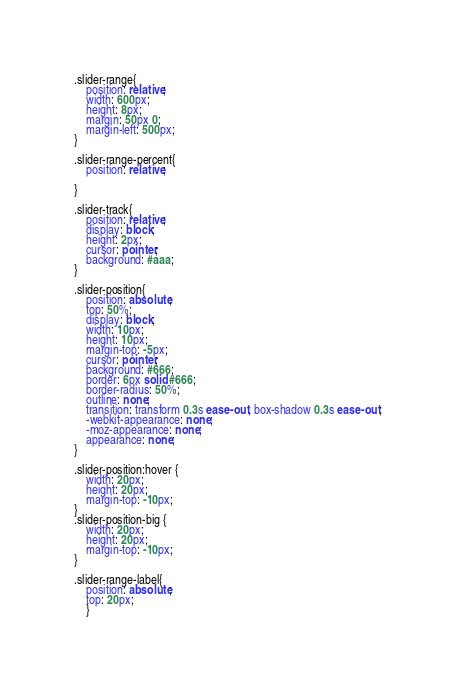<code> <loc_0><loc_0><loc_500><loc_500><_CSS_>.slider-range{
    position: relative;
    width: 600px;
    height: 8px;
    margin: 50px 0;
    margin-left: 500px;
}

.slider-range-percent{
    position: relative;
 
}

.slider-track{
    position: relative;
    display: block;
    height: 2px;
    cursor: pointer;
    background: #aaa;
}

.slider-position{
    position: absolute;
    top: 50%;
    display: block;
    width: 10px;
    height: 10px;
    margin-top: -5px;
    cursor: pointer;
    background: #666;
    border: 6px solid #666;
    border-radius: 50%;
    outline: none;
    transition: transform 0.3s ease-out, box-shadow 0.3s ease-out;
    -webkit-appearance: none;
    -moz-appearance: none;
    appearance: none;
}

.slider-position:hover {
    width: 20px;
    height: 20px;
    margin-top: -10px;
}
.slider-position-big {
    width: 20px;
    height: 20px;
    margin-top: -10px;
}

.slider-range-label{
    position: absolute;
    top: 20px;
    }</code> 